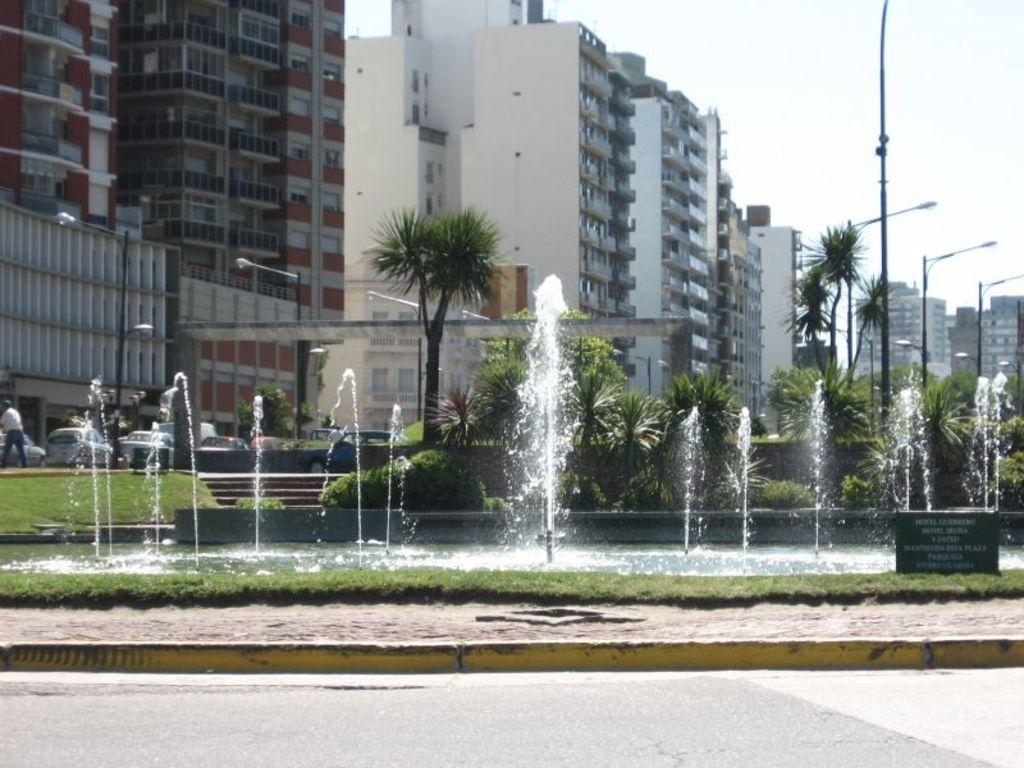What is the main feature in the image? There is a fountain in the image. What can be seen behind the fountain? Trees and buildings are visible behind the fountain. What type of lighting is present on the right side of the image? Streetlights are on the right side of the image. What type of songs can be heard coming from the fountain in the image? There is no indication in the image that the fountain is producing any sounds, let alone songs. 